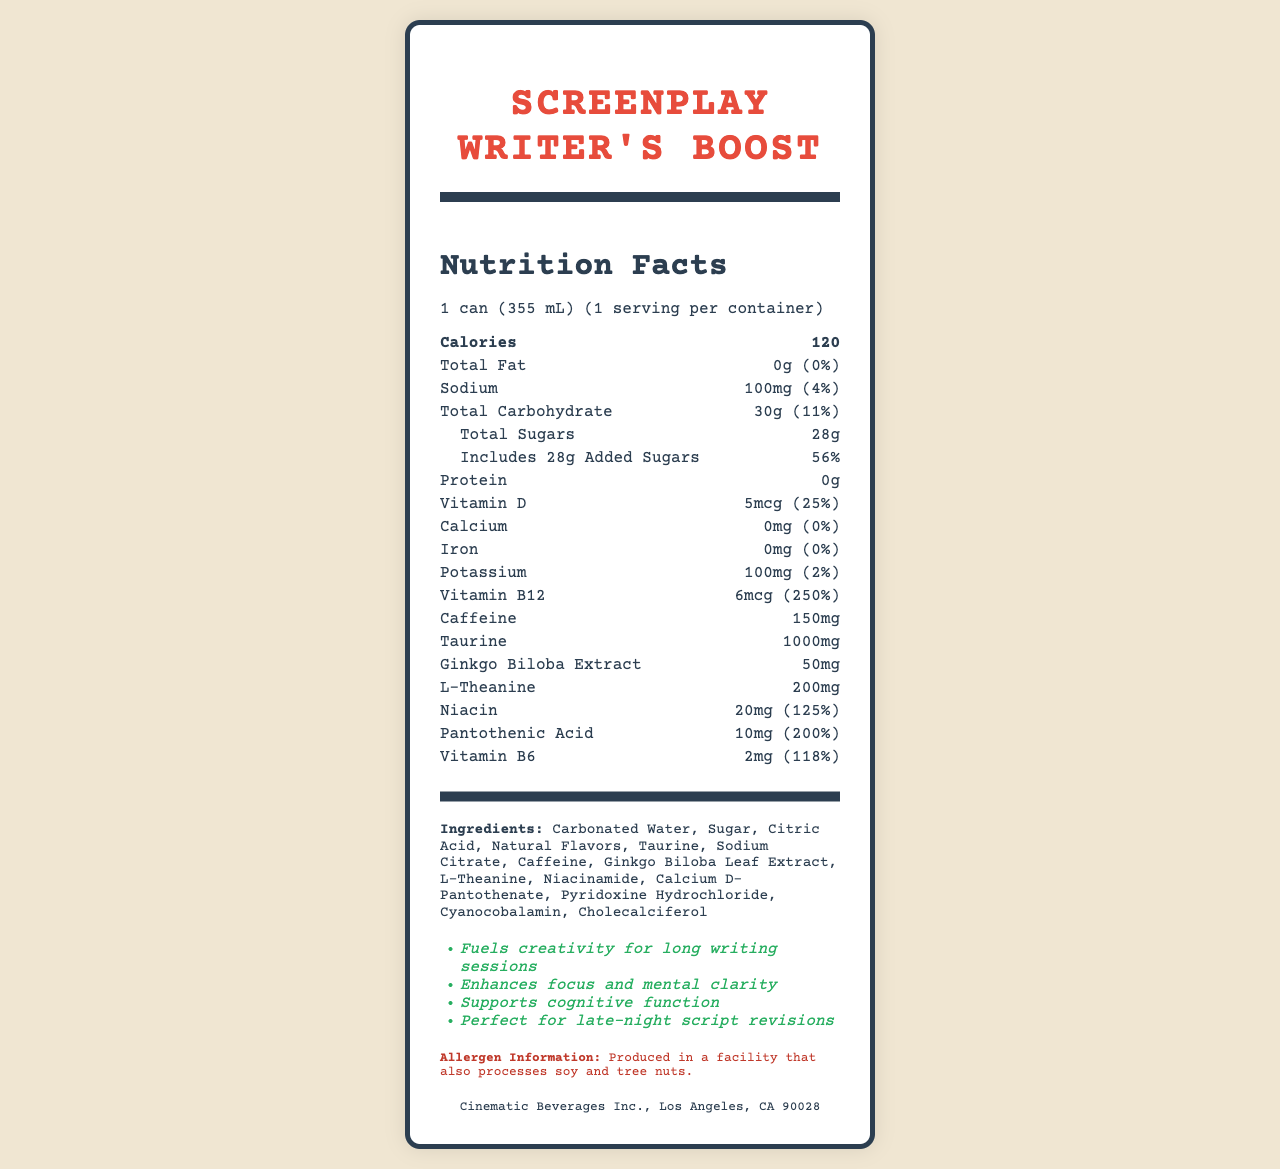what is the serving size? The document states that the serving size is 1 can, which is 355 mL.
Answer: 1 can (355 mL) How many calories are in one serving? The document lists the calories per serving directly as 120.
Answer: 120 What is the total carbohydrate percentage of the daily value? The document shows that the total carbohydrate accounts for 11% of the daily value.
Answer: 11% How much caffeine does one can contain? The document specifies that one can contains 150mg of caffeine.
Answer: 150mg Name one of the marketing claims made about the product. The document includes a list of marketing claims, one of which is "Fuels creativity for long writing sessions."
Answer: Fuels creativity for long writing sessions Which of the following is an ingredient in Screenplay Writer's Boost? A. Carbonated Water B. Milk C. Soy Lecithin D. Honey The document lists Carbonated Water as one of the ingredients.
Answer: A. Carbonated Water How much added sugars are there in the drink per serving? A. 14g B. 20g C. 28g D. 56g The document states that there are 28g of added sugars per serving.
Answer: C. 28g What is the daily value percentage for vitamin B12 in the drink? A. 25% B. 125% C. 200% D. 250% The document specifies that the daily value percentage for vitamin B12 is 250%.
Answer: D. 250% Does the drink contain any protein? The document states that the protein content is 0g.
Answer: No Is the drink produced in a facility that processes soy and tree nuts? The allergen information in the document mentions that it is produced in a facility that also processes soy and tree nuts.
Answer: Yes Summarize the key nutritional information for Screenplay Writer's Boost. The document provides detailed information on the nutritional content including calories, macronutrients, and various vitamins and minerals along with their daily value percentages.
Answer: The drink contains 120 calories per serving with 28g of total sugars (56% of daily value), 11% daily value for total carbohydrates, 100mg of sodium (4% daily value), 250% daily value of vitamin B12, and 25% daily value of vitamin D. It also contains 150mg of caffeine, 1000mg of taurine, and other vitamins and nutrients. How many calories from fat are in the drink? The document does not specify the number of calories from fat; it only mentions that the total fat amount is 0g.
Answer: Not enough information 